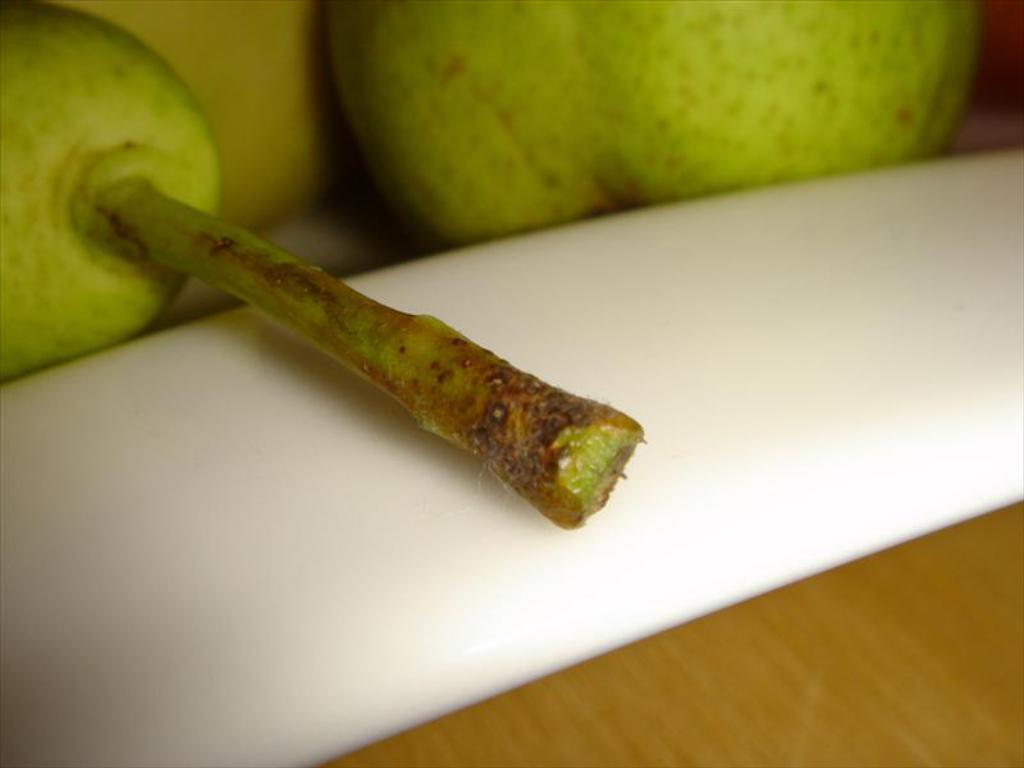What is present in the image in terms of edible items? There are two fruits in the image. Where are the fruits placed? The fruits are on an object. Can you describe the object on which the fruits are placed? The object is on a platform. How many chess pieces can be seen on the platform in the image? There are no chess pieces present in the image; it features two fruits on an object. What type of balance is required to keep the fruits from falling off the object in the image? The image does not show any specific balance requirements, as the fruits are simply placed on the object. 